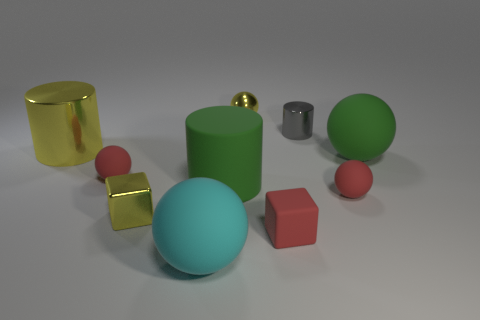Does the gray object have the same shape as the cyan rubber thing?
Your answer should be compact. No. The metal object that is in front of the gray metal object and behind the small metallic block is what color?
Keep it short and to the point. Yellow. There is a block that is the same color as the tiny shiny ball; what size is it?
Offer a terse response. Small. How many tiny things are red cubes or yellow things?
Provide a short and direct response. 3. Are there any other things that have the same color as the tiny metallic cylinder?
Make the answer very short. No. The big thing in front of the big cylinder right of the matte object that is to the left of the cyan sphere is made of what material?
Ensure brevity in your answer.  Rubber. How many matte things are either big cylinders or large yellow objects?
Provide a short and direct response. 1. How many green things are either big things or big spheres?
Keep it short and to the point. 2. Does the matte sphere that is left of the large cyan rubber object have the same color as the rubber block?
Your answer should be compact. Yes. Is the small gray cylinder made of the same material as the large yellow cylinder?
Make the answer very short. Yes. 